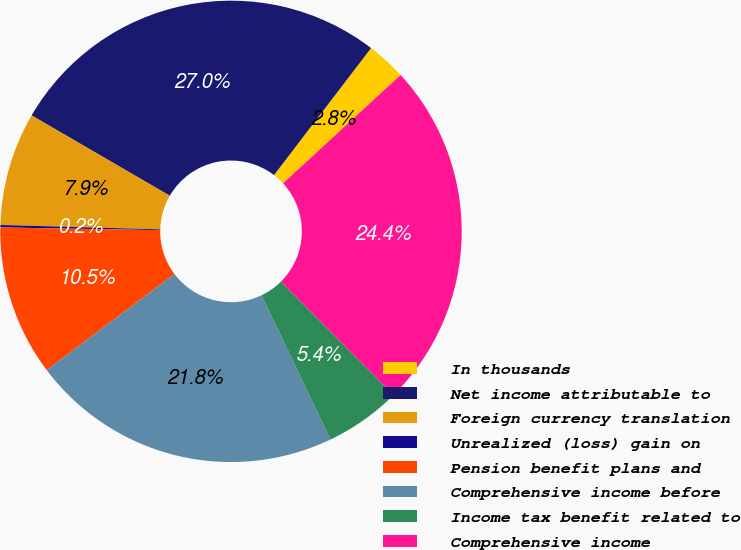Convert chart to OTSL. <chart><loc_0><loc_0><loc_500><loc_500><pie_chart><fcel>In thousands<fcel>Net income attributable to<fcel>Foreign currency translation<fcel>Unrealized (loss) gain on<fcel>Pension benefit plans and<fcel>Comprehensive income before<fcel>Income tax benefit related to<fcel>Comprehensive income<nl><fcel>2.76%<fcel>27.0%<fcel>7.94%<fcel>0.17%<fcel>10.54%<fcel>21.82%<fcel>5.35%<fcel>24.41%<nl></chart> 